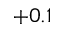Convert formula to latex. <formula><loc_0><loc_0><loc_500><loc_500>+ 0 . 1</formula> 